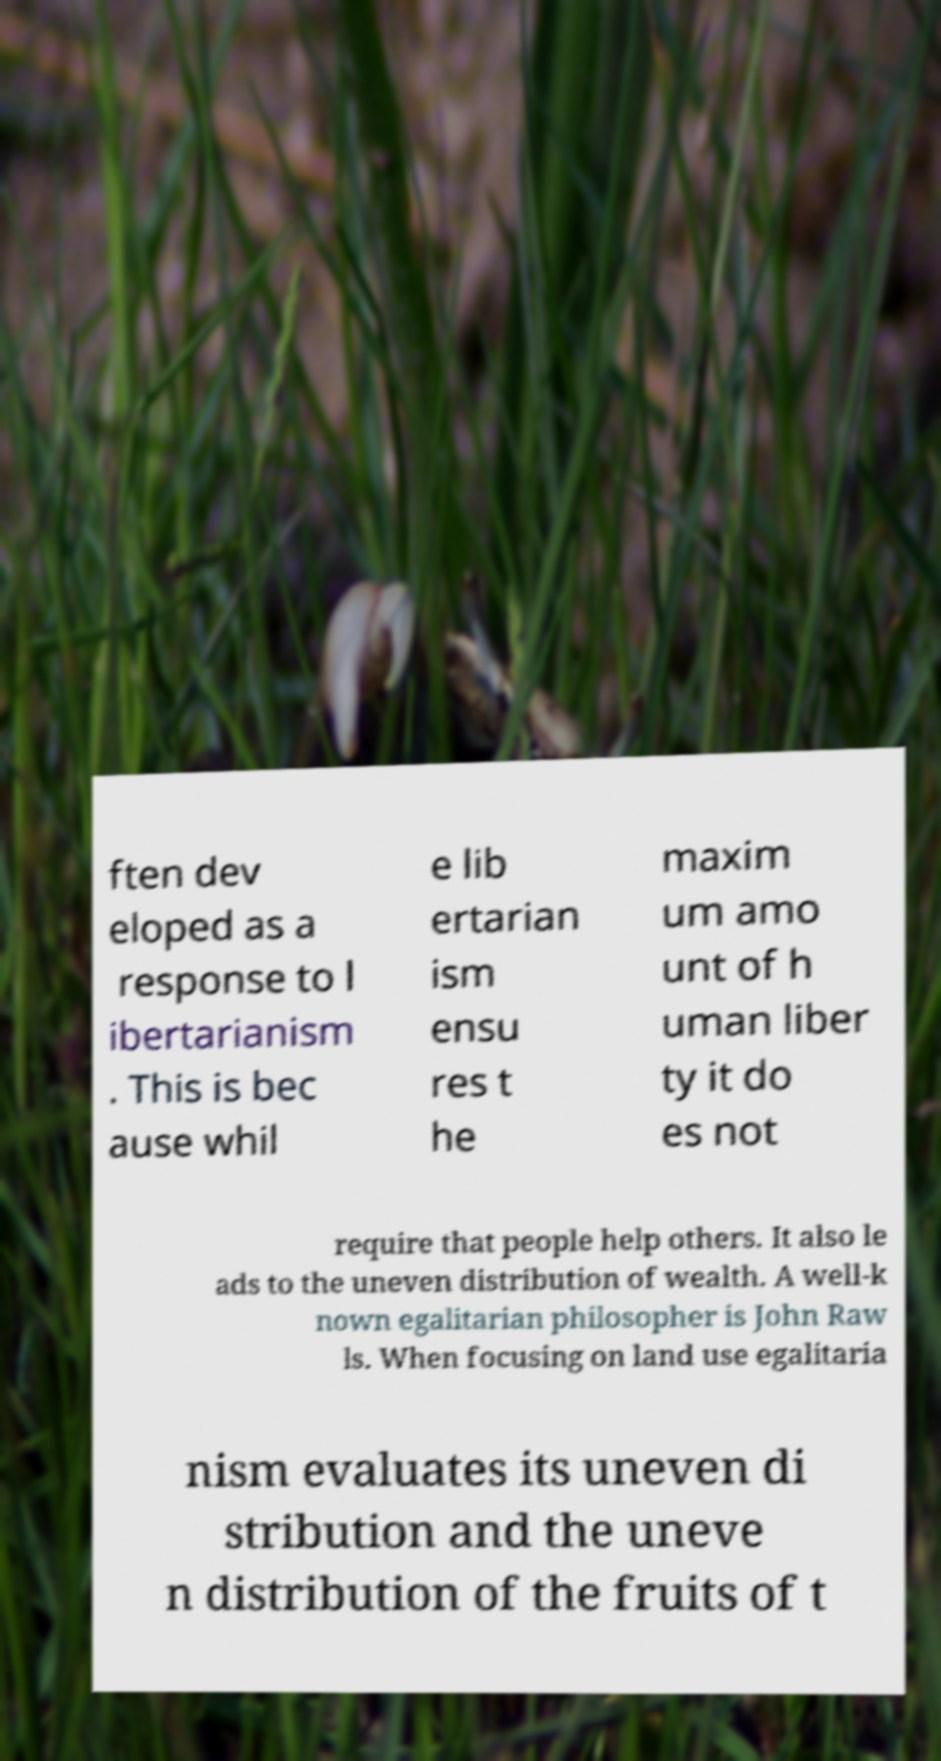Could you assist in decoding the text presented in this image and type it out clearly? ften dev eloped as a response to l ibertarianism . This is bec ause whil e lib ertarian ism ensu res t he maxim um amo unt of h uman liber ty it do es not require that people help others. It also le ads to the uneven distribution of wealth. A well-k nown egalitarian philosopher is John Raw ls. When focusing on land use egalitaria nism evaluates its uneven di stribution and the uneve n distribution of the fruits of t 